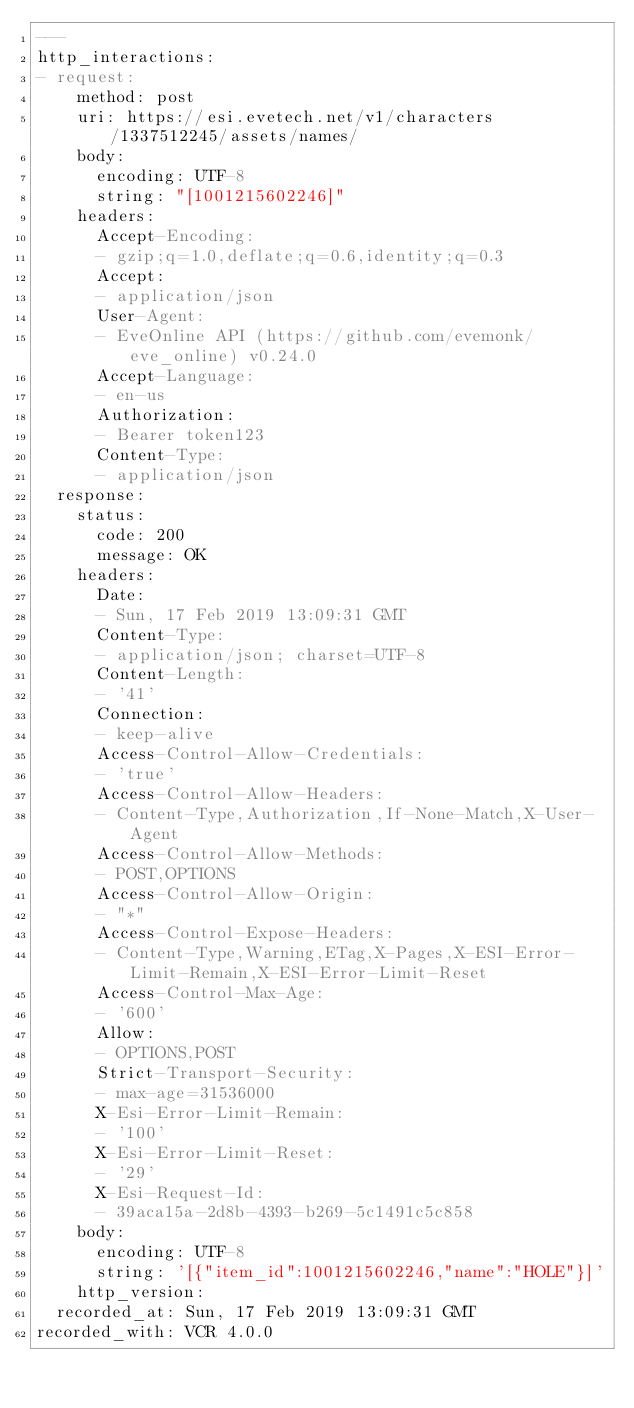<code> <loc_0><loc_0><loc_500><loc_500><_YAML_>---
http_interactions:
- request:
    method: post
    uri: https://esi.evetech.net/v1/characters/1337512245/assets/names/
    body:
      encoding: UTF-8
      string: "[1001215602246]"
    headers:
      Accept-Encoding:
      - gzip;q=1.0,deflate;q=0.6,identity;q=0.3
      Accept:
      - application/json
      User-Agent:
      - EveOnline API (https://github.com/evemonk/eve_online) v0.24.0
      Accept-Language:
      - en-us
      Authorization:
      - Bearer token123
      Content-Type:
      - application/json
  response:
    status:
      code: 200
      message: OK
    headers:
      Date:
      - Sun, 17 Feb 2019 13:09:31 GMT
      Content-Type:
      - application/json; charset=UTF-8
      Content-Length:
      - '41'
      Connection:
      - keep-alive
      Access-Control-Allow-Credentials:
      - 'true'
      Access-Control-Allow-Headers:
      - Content-Type,Authorization,If-None-Match,X-User-Agent
      Access-Control-Allow-Methods:
      - POST,OPTIONS
      Access-Control-Allow-Origin:
      - "*"
      Access-Control-Expose-Headers:
      - Content-Type,Warning,ETag,X-Pages,X-ESI-Error-Limit-Remain,X-ESI-Error-Limit-Reset
      Access-Control-Max-Age:
      - '600'
      Allow:
      - OPTIONS,POST
      Strict-Transport-Security:
      - max-age=31536000
      X-Esi-Error-Limit-Remain:
      - '100'
      X-Esi-Error-Limit-Reset:
      - '29'
      X-Esi-Request-Id:
      - 39aca15a-2d8b-4393-b269-5c1491c5c858
    body:
      encoding: UTF-8
      string: '[{"item_id":1001215602246,"name":"HOLE"}]'
    http_version:
  recorded_at: Sun, 17 Feb 2019 13:09:31 GMT
recorded_with: VCR 4.0.0
</code> 